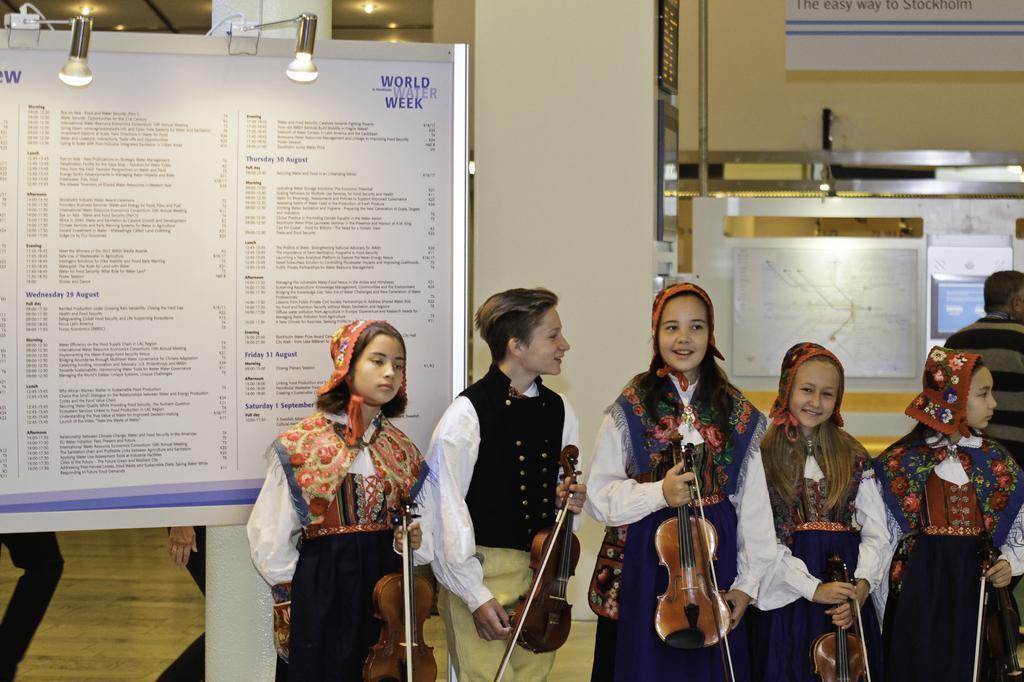Can you describe this image briefly? There are five children standing. On the right side three girls are standing holding violins. They are wearing scarves. Next to them a boy is standing and holding a violin. In the back there is a notice board with lights, pillars, banners, wall and pipes. 